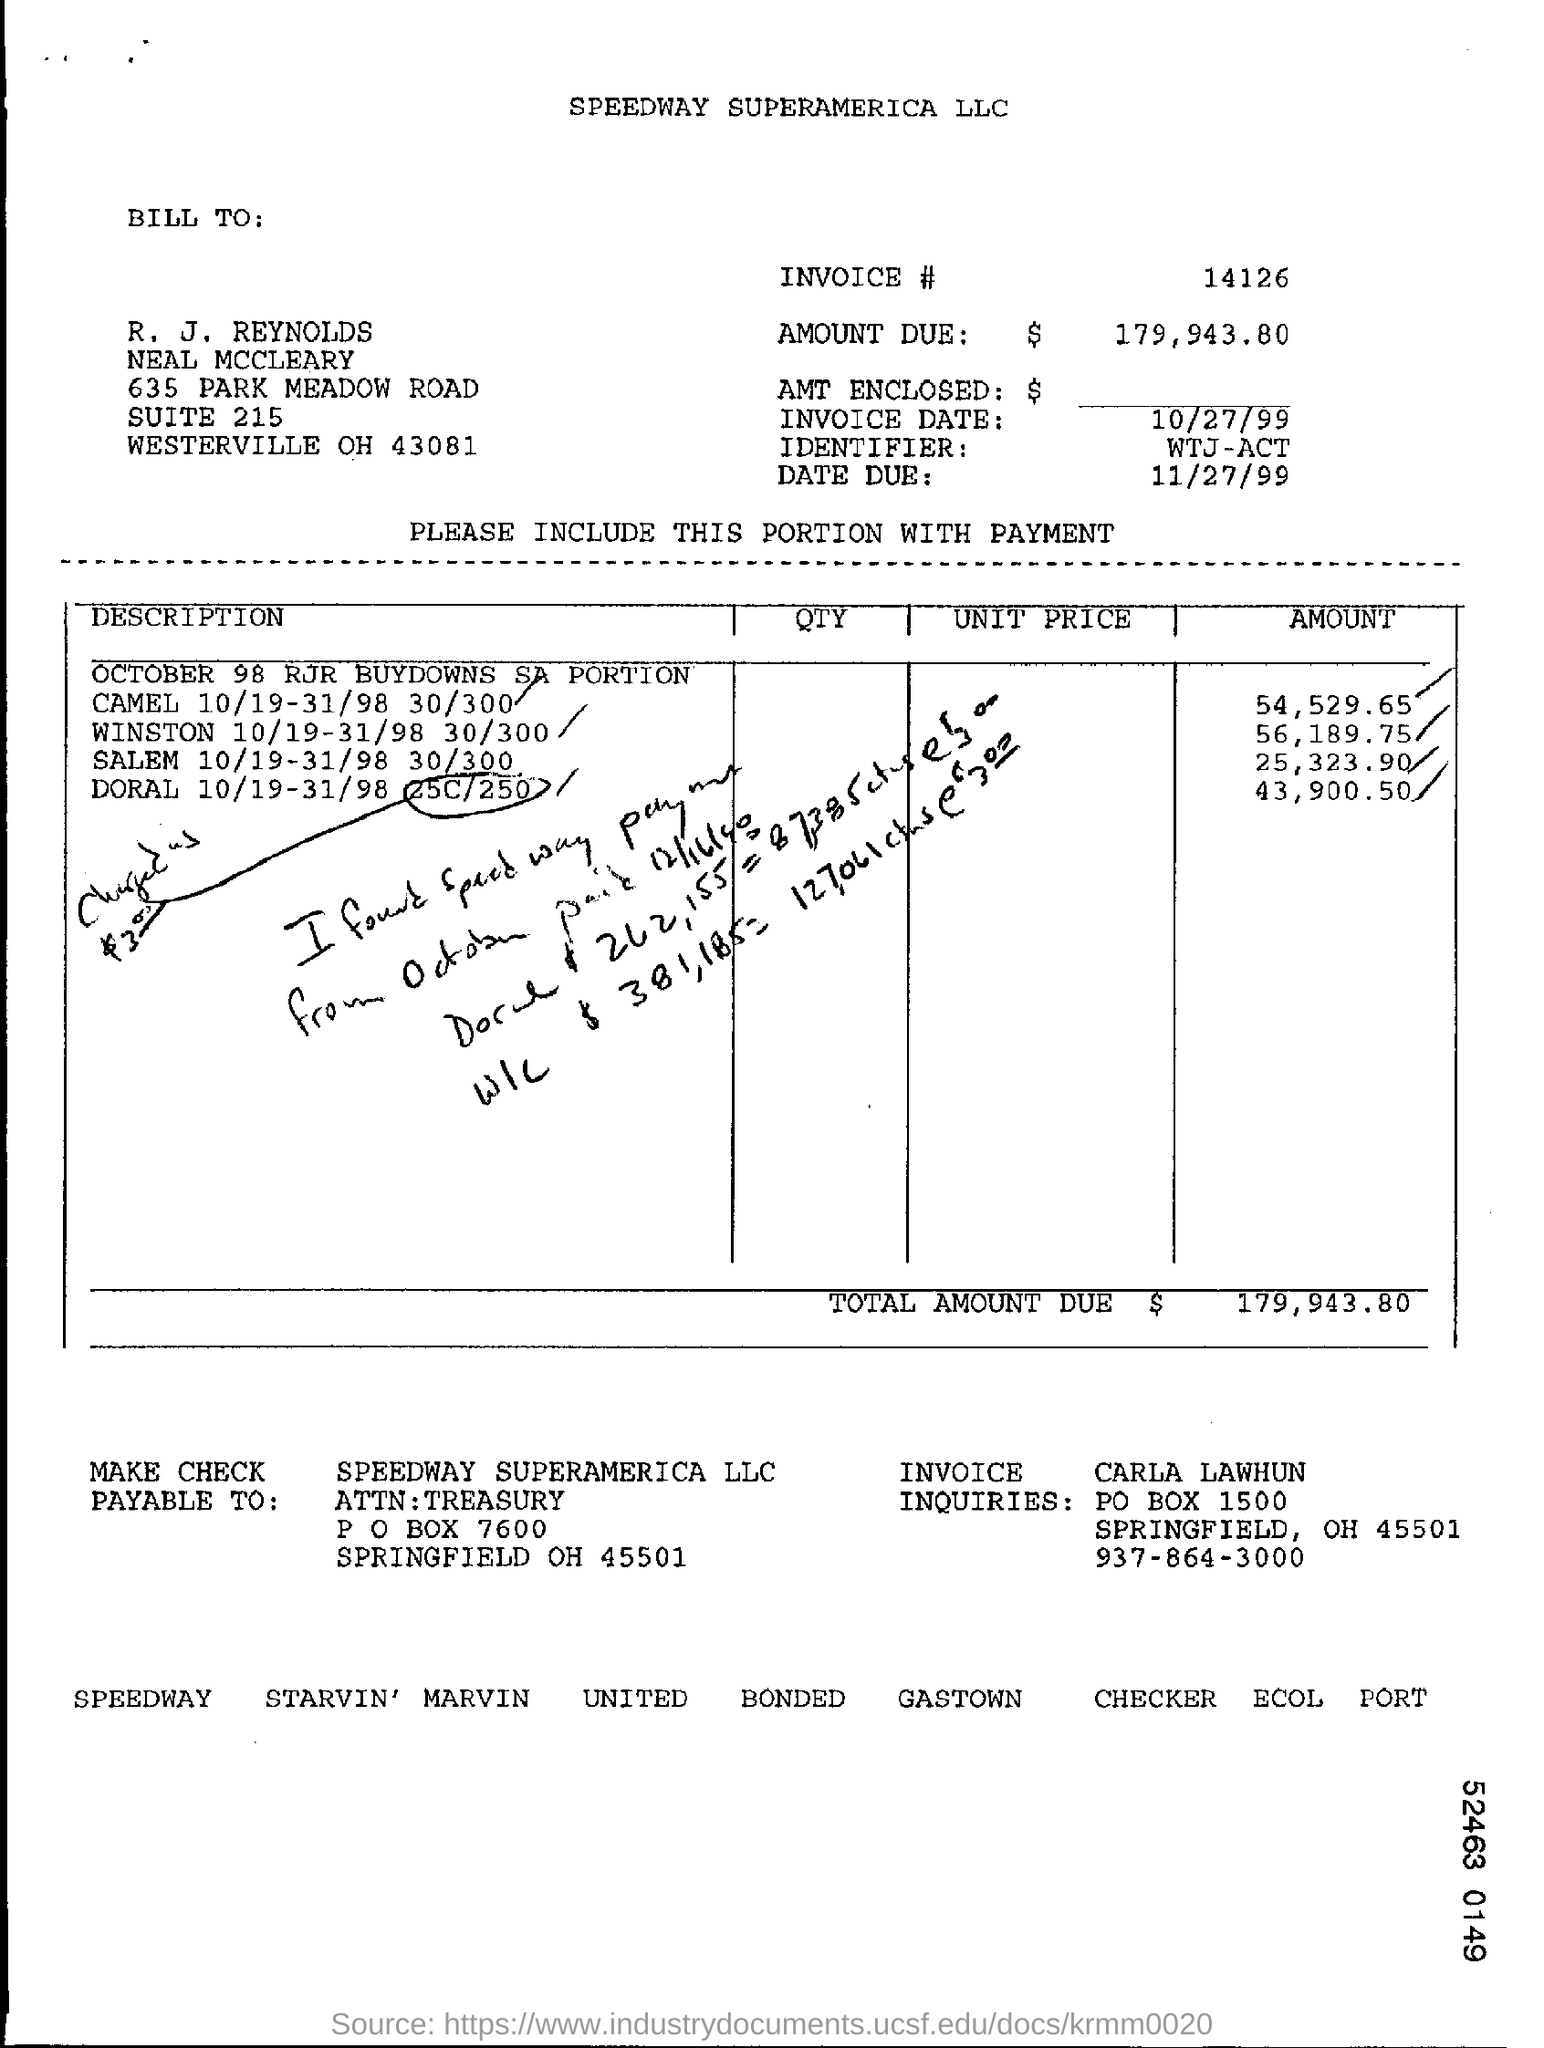Highlight a few significant elements in this photo. The amount for WINSTON's coverage from 10/19/98 to 31/30/98 was 30/300, resulting in a total of 56,189.75. The city in the Billing address is Westerville. The due date is November 27, 1999. The city in the PAY TO Address is SPRINGFIELD. What is the invoice number?" the customer inquired. "14126..." the customer responded. 